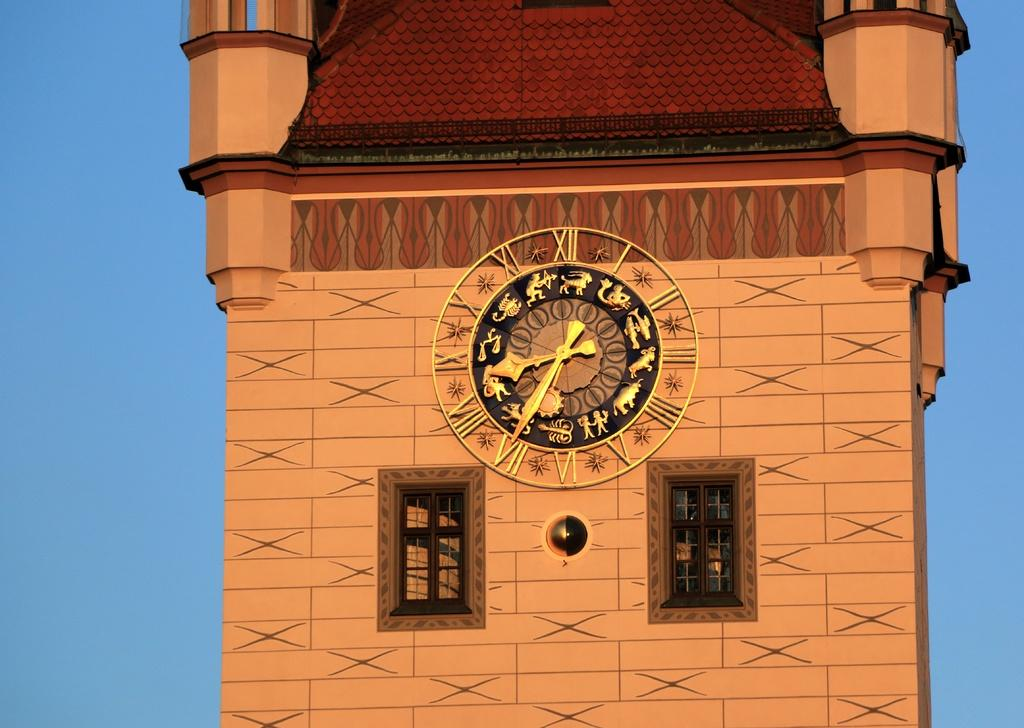What is depicted in the painting that is visible in the image? There is a painting of a clock and a painting of a building in the image. How many windows can be seen in the image? There are two windows in the image. What color is the background of the image? The background of the image is blue in color. Can you tell me how many toys are visible in the image? There are no toys present in the image. Which direction is the clock pointing in the image? The image is a painting of a clock, so it is not a functioning clock and does not have a direction it is pointing. 